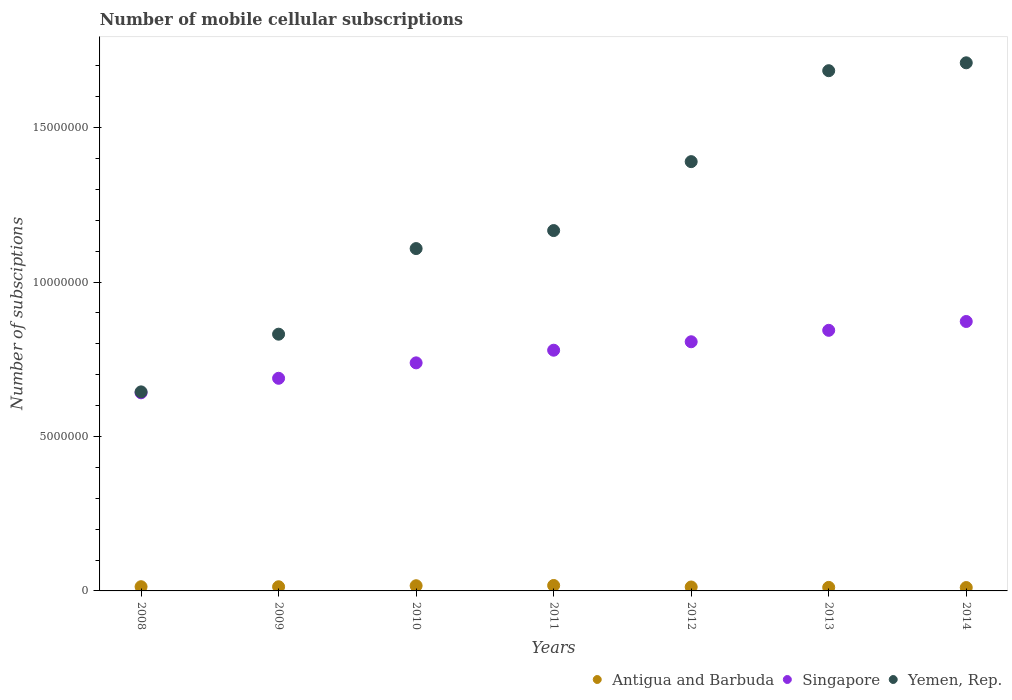How many different coloured dotlines are there?
Your answer should be compact. 3. What is the number of mobile cellular subscriptions in Antigua and Barbuda in 2012?
Offer a terse response. 1.27e+05. Across all years, what is the maximum number of mobile cellular subscriptions in Antigua and Barbuda?
Keep it short and to the point. 1.76e+05. Across all years, what is the minimum number of mobile cellular subscriptions in Yemen, Rep.?
Keep it short and to the point. 6.44e+06. In which year was the number of mobile cellular subscriptions in Antigua and Barbuda maximum?
Provide a succinct answer. 2011. What is the total number of mobile cellular subscriptions in Singapore in the graph?
Provide a short and direct response. 5.37e+07. What is the difference between the number of mobile cellular subscriptions in Singapore in 2009 and that in 2011?
Keep it short and to the point. -9.10e+05. What is the difference between the number of mobile cellular subscriptions in Singapore in 2011 and the number of mobile cellular subscriptions in Antigua and Barbuda in 2013?
Provide a succinct answer. 7.68e+06. What is the average number of mobile cellular subscriptions in Yemen, Rep. per year?
Provide a succinct answer. 1.22e+07. In the year 2008, what is the difference between the number of mobile cellular subscriptions in Singapore and number of mobile cellular subscriptions in Antigua and Barbuda?
Provide a short and direct response. 6.28e+06. In how many years, is the number of mobile cellular subscriptions in Yemen, Rep. greater than 11000000?
Offer a terse response. 5. What is the ratio of the number of mobile cellular subscriptions in Singapore in 2012 to that in 2013?
Your response must be concise. 0.96. What is the difference between the highest and the second highest number of mobile cellular subscriptions in Antigua and Barbuda?
Your answer should be compact. 8038. What is the difference between the highest and the lowest number of mobile cellular subscriptions in Antigua and Barbuda?
Provide a succinct answer. 6.69e+04. Does the number of mobile cellular subscriptions in Yemen, Rep. monotonically increase over the years?
Keep it short and to the point. Yes. Is the number of mobile cellular subscriptions in Singapore strictly greater than the number of mobile cellular subscriptions in Antigua and Barbuda over the years?
Provide a succinct answer. Yes. How many years are there in the graph?
Provide a short and direct response. 7. Does the graph contain any zero values?
Keep it short and to the point. No. Does the graph contain grids?
Give a very brief answer. No. How are the legend labels stacked?
Offer a terse response. Horizontal. What is the title of the graph?
Make the answer very short. Number of mobile cellular subscriptions. What is the label or title of the X-axis?
Provide a short and direct response. Years. What is the label or title of the Y-axis?
Your answer should be compact. Number of subsciptions. What is the Number of subsciptions of Antigua and Barbuda in 2008?
Provide a short and direct response. 1.37e+05. What is the Number of subsciptions of Singapore in 2008?
Offer a very short reply. 6.41e+06. What is the Number of subsciptions of Yemen, Rep. in 2008?
Offer a terse response. 6.44e+06. What is the Number of subsciptions in Antigua and Barbuda in 2009?
Keep it short and to the point. 1.35e+05. What is the Number of subsciptions of Singapore in 2009?
Your response must be concise. 6.88e+06. What is the Number of subsciptions in Yemen, Rep. in 2009?
Provide a short and direct response. 8.31e+06. What is the Number of subsciptions in Antigua and Barbuda in 2010?
Provide a succinct answer. 1.68e+05. What is the Number of subsciptions of Singapore in 2010?
Your answer should be compact. 7.38e+06. What is the Number of subsciptions of Yemen, Rep. in 2010?
Make the answer very short. 1.11e+07. What is the Number of subsciptions of Antigua and Barbuda in 2011?
Offer a terse response. 1.76e+05. What is the Number of subsciptions in Singapore in 2011?
Ensure brevity in your answer.  7.79e+06. What is the Number of subsciptions in Yemen, Rep. in 2011?
Provide a short and direct response. 1.17e+07. What is the Number of subsciptions in Antigua and Barbuda in 2012?
Make the answer very short. 1.27e+05. What is the Number of subsciptions in Singapore in 2012?
Make the answer very short. 8.07e+06. What is the Number of subsciptions of Yemen, Rep. in 2012?
Make the answer very short. 1.39e+07. What is the Number of subsciptions of Antigua and Barbuda in 2013?
Give a very brief answer. 1.14e+05. What is the Number of subsciptions in Singapore in 2013?
Your answer should be very brief. 8.44e+06. What is the Number of subsciptions in Yemen, Rep. in 2013?
Provide a short and direct response. 1.68e+07. What is the Number of subsciptions in Antigua and Barbuda in 2014?
Your answer should be very brief. 1.09e+05. What is the Number of subsciptions of Singapore in 2014?
Offer a very short reply. 8.72e+06. What is the Number of subsciptions of Yemen, Rep. in 2014?
Provide a succinct answer. 1.71e+07. Across all years, what is the maximum Number of subsciptions of Antigua and Barbuda?
Give a very brief answer. 1.76e+05. Across all years, what is the maximum Number of subsciptions in Singapore?
Provide a short and direct response. 8.72e+06. Across all years, what is the maximum Number of subsciptions of Yemen, Rep.?
Offer a very short reply. 1.71e+07. Across all years, what is the minimum Number of subsciptions of Antigua and Barbuda?
Provide a short and direct response. 1.09e+05. Across all years, what is the minimum Number of subsciptions in Singapore?
Provide a short and direct response. 6.41e+06. Across all years, what is the minimum Number of subsciptions in Yemen, Rep.?
Ensure brevity in your answer.  6.44e+06. What is the total Number of subsciptions in Antigua and Barbuda in the graph?
Your response must be concise. 9.66e+05. What is the total Number of subsciptions of Singapore in the graph?
Offer a very short reply. 5.37e+07. What is the total Number of subsciptions of Yemen, Rep. in the graph?
Your answer should be very brief. 8.54e+07. What is the difference between the Number of subsciptions in Antigua and Barbuda in 2008 and that in 2009?
Make the answer very short. 1667. What is the difference between the Number of subsciptions of Singapore in 2008 and that in 2009?
Offer a terse response. -4.70e+05. What is the difference between the Number of subsciptions in Yemen, Rep. in 2008 and that in 2009?
Offer a terse response. -1.87e+06. What is the difference between the Number of subsciptions in Antigua and Barbuda in 2008 and that in 2010?
Give a very brief answer. -3.14e+04. What is the difference between the Number of subsciptions of Singapore in 2008 and that in 2010?
Offer a very short reply. -9.70e+05. What is the difference between the Number of subsciptions of Yemen, Rep. in 2008 and that in 2010?
Your answer should be compact. -4.64e+06. What is the difference between the Number of subsciptions in Antigua and Barbuda in 2008 and that in 2011?
Ensure brevity in your answer.  -3.94e+04. What is the difference between the Number of subsciptions of Singapore in 2008 and that in 2011?
Ensure brevity in your answer.  -1.38e+06. What is the difference between the Number of subsciptions of Yemen, Rep. in 2008 and that in 2011?
Your answer should be compact. -5.22e+06. What is the difference between the Number of subsciptions of Antigua and Barbuda in 2008 and that in 2012?
Keep it short and to the point. 9211. What is the difference between the Number of subsciptions of Singapore in 2008 and that in 2012?
Provide a succinct answer. -1.65e+06. What is the difference between the Number of subsciptions in Yemen, Rep. in 2008 and that in 2012?
Make the answer very short. -7.46e+06. What is the difference between the Number of subsciptions in Antigua and Barbuda in 2008 and that in 2013?
Your answer should be compact. 2.22e+04. What is the difference between the Number of subsciptions in Singapore in 2008 and that in 2013?
Give a very brief answer. -2.02e+06. What is the difference between the Number of subsciptions in Yemen, Rep. in 2008 and that in 2013?
Keep it short and to the point. -1.04e+07. What is the difference between the Number of subsciptions of Antigua and Barbuda in 2008 and that in 2014?
Offer a terse response. 2.75e+04. What is the difference between the Number of subsciptions in Singapore in 2008 and that in 2014?
Provide a short and direct response. -2.31e+06. What is the difference between the Number of subsciptions of Yemen, Rep. in 2008 and that in 2014?
Provide a short and direct response. -1.07e+07. What is the difference between the Number of subsciptions in Antigua and Barbuda in 2009 and that in 2010?
Keep it short and to the point. -3.30e+04. What is the difference between the Number of subsciptions of Singapore in 2009 and that in 2010?
Offer a terse response. -5.00e+05. What is the difference between the Number of subsciptions of Yemen, Rep. in 2009 and that in 2010?
Provide a short and direct response. -2.77e+06. What is the difference between the Number of subsciptions in Antigua and Barbuda in 2009 and that in 2011?
Keep it short and to the point. -4.11e+04. What is the difference between the Number of subsciptions of Singapore in 2009 and that in 2011?
Offer a very short reply. -9.10e+05. What is the difference between the Number of subsciptions in Yemen, Rep. in 2009 and that in 2011?
Give a very brief answer. -3.36e+06. What is the difference between the Number of subsciptions in Antigua and Barbuda in 2009 and that in 2012?
Your answer should be compact. 7544. What is the difference between the Number of subsciptions of Singapore in 2009 and that in 2012?
Your answer should be compact. -1.18e+06. What is the difference between the Number of subsciptions of Yemen, Rep. in 2009 and that in 2012?
Ensure brevity in your answer.  -5.59e+06. What is the difference between the Number of subsciptions of Antigua and Barbuda in 2009 and that in 2013?
Your answer should be compact. 2.06e+04. What is the difference between the Number of subsciptions in Singapore in 2009 and that in 2013?
Provide a succinct answer. -1.55e+06. What is the difference between the Number of subsciptions in Yemen, Rep. in 2009 and that in 2013?
Make the answer very short. -8.53e+06. What is the difference between the Number of subsciptions in Antigua and Barbuda in 2009 and that in 2014?
Ensure brevity in your answer.  2.58e+04. What is the difference between the Number of subsciptions in Singapore in 2009 and that in 2014?
Give a very brief answer. -1.84e+06. What is the difference between the Number of subsciptions in Yemen, Rep. in 2009 and that in 2014?
Provide a succinct answer. -8.79e+06. What is the difference between the Number of subsciptions in Antigua and Barbuda in 2010 and that in 2011?
Offer a very short reply. -8038. What is the difference between the Number of subsciptions of Singapore in 2010 and that in 2011?
Your answer should be very brief. -4.10e+05. What is the difference between the Number of subsciptions of Yemen, Rep. in 2010 and that in 2011?
Your response must be concise. -5.83e+05. What is the difference between the Number of subsciptions of Antigua and Barbuda in 2010 and that in 2012?
Offer a very short reply. 4.06e+04. What is the difference between the Number of subsciptions of Singapore in 2010 and that in 2012?
Your response must be concise. -6.83e+05. What is the difference between the Number of subsciptions in Yemen, Rep. in 2010 and that in 2012?
Your answer should be compact. -2.82e+06. What is the difference between the Number of subsciptions of Antigua and Barbuda in 2010 and that in 2013?
Ensure brevity in your answer.  5.36e+04. What is the difference between the Number of subsciptions of Singapore in 2010 and that in 2013?
Offer a very short reply. -1.05e+06. What is the difference between the Number of subsciptions in Yemen, Rep. in 2010 and that in 2013?
Your response must be concise. -5.76e+06. What is the difference between the Number of subsciptions of Antigua and Barbuda in 2010 and that in 2014?
Offer a terse response. 5.89e+04. What is the difference between the Number of subsciptions in Singapore in 2010 and that in 2014?
Provide a short and direct response. -1.34e+06. What is the difference between the Number of subsciptions of Yemen, Rep. in 2010 and that in 2014?
Your response must be concise. -6.02e+06. What is the difference between the Number of subsciptions of Antigua and Barbuda in 2011 and that in 2012?
Provide a short and direct response. 4.86e+04. What is the difference between the Number of subsciptions of Singapore in 2011 and that in 2012?
Provide a succinct answer. -2.73e+05. What is the difference between the Number of subsciptions of Yemen, Rep. in 2011 and that in 2012?
Offer a terse response. -2.23e+06. What is the difference between the Number of subsciptions in Antigua and Barbuda in 2011 and that in 2013?
Provide a succinct answer. 6.16e+04. What is the difference between the Number of subsciptions of Singapore in 2011 and that in 2013?
Keep it short and to the point. -6.44e+05. What is the difference between the Number of subsciptions in Yemen, Rep. in 2011 and that in 2013?
Ensure brevity in your answer.  -5.18e+06. What is the difference between the Number of subsciptions in Antigua and Barbuda in 2011 and that in 2014?
Offer a very short reply. 6.69e+04. What is the difference between the Number of subsciptions of Singapore in 2011 and that in 2014?
Offer a terse response. -9.30e+05. What is the difference between the Number of subsciptions of Yemen, Rep. in 2011 and that in 2014?
Provide a short and direct response. -5.43e+06. What is the difference between the Number of subsciptions of Antigua and Barbuda in 2012 and that in 2013?
Offer a very short reply. 1.30e+04. What is the difference between the Number of subsciptions of Singapore in 2012 and that in 2013?
Offer a very short reply. -3.70e+05. What is the difference between the Number of subsciptions in Yemen, Rep. in 2012 and that in 2013?
Your answer should be very brief. -2.94e+06. What is the difference between the Number of subsciptions in Antigua and Barbuda in 2012 and that in 2014?
Offer a very short reply. 1.83e+04. What is the difference between the Number of subsciptions in Singapore in 2012 and that in 2014?
Provide a short and direct response. -6.57e+05. What is the difference between the Number of subsciptions of Yemen, Rep. in 2012 and that in 2014?
Keep it short and to the point. -3.20e+06. What is the difference between the Number of subsciptions of Antigua and Barbuda in 2013 and that in 2014?
Your answer should be compact. 5258. What is the difference between the Number of subsciptions in Singapore in 2013 and that in 2014?
Offer a terse response. -2.86e+05. What is the difference between the Number of subsciptions of Yemen, Rep. in 2013 and that in 2014?
Your response must be concise. -2.55e+05. What is the difference between the Number of subsciptions of Antigua and Barbuda in 2008 and the Number of subsciptions of Singapore in 2009?
Provide a short and direct response. -6.75e+06. What is the difference between the Number of subsciptions of Antigua and Barbuda in 2008 and the Number of subsciptions of Yemen, Rep. in 2009?
Give a very brief answer. -8.18e+06. What is the difference between the Number of subsciptions in Singapore in 2008 and the Number of subsciptions in Yemen, Rep. in 2009?
Your response must be concise. -1.90e+06. What is the difference between the Number of subsciptions in Antigua and Barbuda in 2008 and the Number of subsciptions in Singapore in 2010?
Provide a short and direct response. -7.25e+06. What is the difference between the Number of subsciptions in Antigua and Barbuda in 2008 and the Number of subsciptions in Yemen, Rep. in 2010?
Provide a short and direct response. -1.09e+07. What is the difference between the Number of subsciptions of Singapore in 2008 and the Number of subsciptions of Yemen, Rep. in 2010?
Your answer should be very brief. -4.67e+06. What is the difference between the Number of subsciptions of Antigua and Barbuda in 2008 and the Number of subsciptions of Singapore in 2011?
Your answer should be very brief. -7.66e+06. What is the difference between the Number of subsciptions of Antigua and Barbuda in 2008 and the Number of subsciptions of Yemen, Rep. in 2011?
Give a very brief answer. -1.15e+07. What is the difference between the Number of subsciptions in Singapore in 2008 and the Number of subsciptions in Yemen, Rep. in 2011?
Provide a short and direct response. -5.25e+06. What is the difference between the Number of subsciptions of Antigua and Barbuda in 2008 and the Number of subsciptions of Singapore in 2012?
Ensure brevity in your answer.  -7.93e+06. What is the difference between the Number of subsciptions of Antigua and Barbuda in 2008 and the Number of subsciptions of Yemen, Rep. in 2012?
Make the answer very short. -1.38e+07. What is the difference between the Number of subsciptions of Singapore in 2008 and the Number of subsciptions of Yemen, Rep. in 2012?
Your answer should be very brief. -7.49e+06. What is the difference between the Number of subsciptions in Antigua and Barbuda in 2008 and the Number of subsciptions in Singapore in 2013?
Offer a terse response. -8.30e+06. What is the difference between the Number of subsciptions of Antigua and Barbuda in 2008 and the Number of subsciptions of Yemen, Rep. in 2013?
Your response must be concise. -1.67e+07. What is the difference between the Number of subsciptions of Singapore in 2008 and the Number of subsciptions of Yemen, Rep. in 2013?
Offer a very short reply. -1.04e+07. What is the difference between the Number of subsciptions in Antigua and Barbuda in 2008 and the Number of subsciptions in Singapore in 2014?
Provide a succinct answer. -8.59e+06. What is the difference between the Number of subsciptions in Antigua and Barbuda in 2008 and the Number of subsciptions in Yemen, Rep. in 2014?
Offer a terse response. -1.70e+07. What is the difference between the Number of subsciptions of Singapore in 2008 and the Number of subsciptions of Yemen, Rep. in 2014?
Offer a terse response. -1.07e+07. What is the difference between the Number of subsciptions of Antigua and Barbuda in 2009 and the Number of subsciptions of Singapore in 2010?
Make the answer very short. -7.25e+06. What is the difference between the Number of subsciptions in Antigua and Barbuda in 2009 and the Number of subsciptions in Yemen, Rep. in 2010?
Offer a terse response. -1.10e+07. What is the difference between the Number of subsciptions of Singapore in 2009 and the Number of subsciptions of Yemen, Rep. in 2010?
Your answer should be compact. -4.20e+06. What is the difference between the Number of subsciptions in Antigua and Barbuda in 2009 and the Number of subsciptions in Singapore in 2011?
Ensure brevity in your answer.  -7.66e+06. What is the difference between the Number of subsciptions of Antigua and Barbuda in 2009 and the Number of subsciptions of Yemen, Rep. in 2011?
Make the answer very short. -1.15e+07. What is the difference between the Number of subsciptions of Singapore in 2009 and the Number of subsciptions of Yemen, Rep. in 2011?
Ensure brevity in your answer.  -4.78e+06. What is the difference between the Number of subsciptions of Antigua and Barbuda in 2009 and the Number of subsciptions of Singapore in 2012?
Provide a succinct answer. -7.93e+06. What is the difference between the Number of subsciptions of Antigua and Barbuda in 2009 and the Number of subsciptions of Yemen, Rep. in 2012?
Your answer should be very brief. -1.38e+07. What is the difference between the Number of subsciptions in Singapore in 2009 and the Number of subsciptions in Yemen, Rep. in 2012?
Make the answer very short. -7.02e+06. What is the difference between the Number of subsciptions in Antigua and Barbuda in 2009 and the Number of subsciptions in Singapore in 2013?
Your answer should be compact. -8.30e+06. What is the difference between the Number of subsciptions of Antigua and Barbuda in 2009 and the Number of subsciptions of Yemen, Rep. in 2013?
Offer a terse response. -1.67e+07. What is the difference between the Number of subsciptions in Singapore in 2009 and the Number of subsciptions in Yemen, Rep. in 2013?
Make the answer very short. -9.96e+06. What is the difference between the Number of subsciptions of Antigua and Barbuda in 2009 and the Number of subsciptions of Singapore in 2014?
Keep it short and to the point. -8.59e+06. What is the difference between the Number of subsciptions of Antigua and Barbuda in 2009 and the Number of subsciptions of Yemen, Rep. in 2014?
Your answer should be very brief. -1.70e+07. What is the difference between the Number of subsciptions of Singapore in 2009 and the Number of subsciptions of Yemen, Rep. in 2014?
Give a very brief answer. -1.02e+07. What is the difference between the Number of subsciptions in Antigua and Barbuda in 2010 and the Number of subsciptions in Singapore in 2011?
Your answer should be compact. -7.63e+06. What is the difference between the Number of subsciptions of Antigua and Barbuda in 2010 and the Number of subsciptions of Yemen, Rep. in 2011?
Provide a succinct answer. -1.15e+07. What is the difference between the Number of subsciptions in Singapore in 2010 and the Number of subsciptions in Yemen, Rep. in 2011?
Provide a short and direct response. -4.28e+06. What is the difference between the Number of subsciptions of Antigua and Barbuda in 2010 and the Number of subsciptions of Singapore in 2012?
Your answer should be very brief. -7.90e+06. What is the difference between the Number of subsciptions in Antigua and Barbuda in 2010 and the Number of subsciptions in Yemen, Rep. in 2012?
Provide a short and direct response. -1.37e+07. What is the difference between the Number of subsciptions of Singapore in 2010 and the Number of subsciptions of Yemen, Rep. in 2012?
Provide a short and direct response. -6.52e+06. What is the difference between the Number of subsciptions of Antigua and Barbuda in 2010 and the Number of subsciptions of Singapore in 2013?
Provide a short and direct response. -8.27e+06. What is the difference between the Number of subsciptions in Antigua and Barbuda in 2010 and the Number of subsciptions in Yemen, Rep. in 2013?
Make the answer very short. -1.67e+07. What is the difference between the Number of subsciptions in Singapore in 2010 and the Number of subsciptions in Yemen, Rep. in 2013?
Provide a succinct answer. -9.46e+06. What is the difference between the Number of subsciptions in Antigua and Barbuda in 2010 and the Number of subsciptions in Singapore in 2014?
Your answer should be very brief. -8.56e+06. What is the difference between the Number of subsciptions in Antigua and Barbuda in 2010 and the Number of subsciptions in Yemen, Rep. in 2014?
Provide a succinct answer. -1.69e+07. What is the difference between the Number of subsciptions in Singapore in 2010 and the Number of subsciptions in Yemen, Rep. in 2014?
Provide a short and direct response. -9.72e+06. What is the difference between the Number of subsciptions of Antigua and Barbuda in 2011 and the Number of subsciptions of Singapore in 2012?
Provide a succinct answer. -7.89e+06. What is the difference between the Number of subsciptions in Antigua and Barbuda in 2011 and the Number of subsciptions in Yemen, Rep. in 2012?
Provide a short and direct response. -1.37e+07. What is the difference between the Number of subsciptions of Singapore in 2011 and the Number of subsciptions of Yemen, Rep. in 2012?
Your answer should be very brief. -6.11e+06. What is the difference between the Number of subsciptions in Antigua and Barbuda in 2011 and the Number of subsciptions in Singapore in 2013?
Your answer should be very brief. -8.26e+06. What is the difference between the Number of subsciptions in Antigua and Barbuda in 2011 and the Number of subsciptions in Yemen, Rep. in 2013?
Provide a short and direct response. -1.67e+07. What is the difference between the Number of subsciptions of Singapore in 2011 and the Number of subsciptions of Yemen, Rep. in 2013?
Make the answer very short. -9.05e+06. What is the difference between the Number of subsciptions of Antigua and Barbuda in 2011 and the Number of subsciptions of Singapore in 2014?
Provide a short and direct response. -8.55e+06. What is the difference between the Number of subsciptions of Antigua and Barbuda in 2011 and the Number of subsciptions of Yemen, Rep. in 2014?
Provide a succinct answer. -1.69e+07. What is the difference between the Number of subsciptions in Singapore in 2011 and the Number of subsciptions in Yemen, Rep. in 2014?
Offer a terse response. -9.31e+06. What is the difference between the Number of subsciptions in Antigua and Barbuda in 2012 and the Number of subsciptions in Singapore in 2013?
Offer a terse response. -8.31e+06. What is the difference between the Number of subsciptions in Antigua and Barbuda in 2012 and the Number of subsciptions in Yemen, Rep. in 2013?
Offer a very short reply. -1.67e+07. What is the difference between the Number of subsciptions of Singapore in 2012 and the Number of subsciptions of Yemen, Rep. in 2013?
Provide a short and direct response. -8.78e+06. What is the difference between the Number of subsciptions of Antigua and Barbuda in 2012 and the Number of subsciptions of Singapore in 2014?
Give a very brief answer. -8.60e+06. What is the difference between the Number of subsciptions in Antigua and Barbuda in 2012 and the Number of subsciptions in Yemen, Rep. in 2014?
Keep it short and to the point. -1.70e+07. What is the difference between the Number of subsciptions of Singapore in 2012 and the Number of subsciptions of Yemen, Rep. in 2014?
Provide a short and direct response. -9.03e+06. What is the difference between the Number of subsciptions in Antigua and Barbuda in 2013 and the Number of subsciptions in Singapore in 2014?
Make the answer very short. -8.61e+06. What is the difference between the Number of subsciptions in Antigua and Barbuda in 2013 and the Number of subsciptions in Yemen, Rep. in 2014?
Provide a short and direct response. -1.70e+07. What is the difference between the Number of subsciptions of Singapore in 2013 and the Number of subsciptions of Yemen, Rep. in 2014?
Offer a terse response. -8.66e+06. What is the average Number of subsciptions in Antigua and Barbuda per year?
Provide a succinct answer. 1.38e+05. What is the average Number of subsciptions in Singapore per year?
Provide a short and direct response. 7.67e+06. What is the average Number of subsciptions in Yemen, Rep. per year?
Your answer should be compact. 1.22e+07. In the year 2008, what is the difference between the Number of subsciptions of Antigua and Barbuda and Number of subsciptions of Singapore?
Keep it short and to the point. -6.28e+06. In the year 2008, what is the difference between the Number of subsciptions in Antigua and Barbuda and Number of subsciptions in Yemen, Rep.?
Offer a very short reply. -6.31e+06. In the year 2008, what is the difference between the Number of subsciptions in Singapore and Number of subsciptions in Yemen, Rep.?
Provide a short and direct response. -3.02e+04. In the year 2009, what is the difference between the Number of subsciptions of Antigua and Barbuda and Number of subsciptions of Singapore?
Ensure brevity in your answer.  -6.75e+06. In the year 2009, what is the difference between the Number of subsciptions in Antigua and Barbuda and Number of subsciptions in Yemen, Rep.?
Make the answer very short. -8.18e+06. In the year 2009, what is the difference between the Number of subsciptions in Singapore and Number of subsciptions in Yemen, Rep.?
Give a very brief answer. -1.43e+06. In the year 2010, what is the difference between the Number of subsciptions of Antigua and Barbuda and Number of subsciptions of Singapore?
Your response must be concise. -7.22e+06. In the year 2010, what is the difference between the Number of subsciptions of Antigua and Barbuda and Number of subsciptions of Yemen, Rep.?
Offer a terse response. -1.09e+07. In the year 2010, what is the difference between the Number of subsciptions of Singapore and Number of subsciptions of Yemen, Rep.?
Provide a short and direct response. -3.70e+06. In the year 2011, what is the difference between the Number of subsciptions of Antigua and Barbuda and Number of subsciptions of Singapore?
Make the answer very short. -7.62e+06. In the year 2011, what is the difference between the Number of subsciptions in Antigua and Barbuda and Number of subsciptions in Yemen, Rep.?
Offer a terse response. -1.15e+07. In the year 2011, what is the difference between the Number of subsciptions of Singapore and Number of subsciptions of Yemen, Rep.?
Make the answer very short. -3.87e+06. In the year 2012, what is the difference between the Number of subsciptions of Antigua and Barbuda and Number of subsciptions of Singapore?
Ensure brevity in your answer.  -7.94e+06. In the year 2012, what is the difference between the Number of subsciptions in Antigua and Barbuda and Number of subsciptions in Yemen, Rep.?
Offer a terse response. -1.38e+07. In the year 2012, what is the difference between the Number of subsciptions in Singapore and Number of subsciptions in Yemen, Rep.?
Your answer should be very brief. -5.83e+06. In the year 2013, what is the difference between the Number of subsciptions of Antigua and Barbuda and Number of subsciptions of Singapore?
Give a very brief answer. -8.32e+06. In the year 2013, what is the difference between the Number of subsciptions of Antigua and Barbuda and Number of subsciptions of Yemen, Rep.?
Provide a succinct answer. -1.67e+07. In the year 2013, what is the difference between the Number of subsciptions of Singapore and Number of subsciptions of Yemen, Rep.?
Offer a very short reply. -8.41e+06. In the year 2014, what is the difference between the Number of subsciptions in Antigua and Barbuda and Number of subsciptions in Singapore?
Make the answer very short. -8.62e+06. In the year 2014, what is the difference between the Number of subsciptions of Antigua and Barbuda and Number of subsciptions of Yemen, Rep.?
Your response must be concise. -1.70e+07. In the year 2014, what is the difference between the Number of subsciptions in Singapore and Number of subsciptions in Yemen, Rep.?
Your answer should be very brief. -8.38e+06. What is the ratio of the Number of subsciptions of Antigua and Barbuda in 2008 to that in 2009?
Make the answer very short. 1.01. What is the ratio of the Number of subsciptions in Singapore in 2008 to that in 2009?
Ensure brevity in your answer.  0.93. What is the ratio of the Number of subsciptions in Yemen, Rep. in 2008 to that in 2009?
Make the answer very short. 0.78. What is the ratio of the Number of subsciptions in Antigua and Barbuda in 2008 to that in 2010?
Offer a very short reply. 0.81. What is the ratio of the Number of subsciptions in Singapore in 2008 to that in 2010?
Provide a short and direct response. 0.87. What is the ratio of the Number of subsciptions of Yemen, Rep. in 2008 to that in 2010?
Your response must be concise. 0.58. What is the ratio of the Number of subsciptions of Antigua and Barbuda in 2008 to that in 2011?
Offer a very short reply. 0.78. What is the ratio of the Number of subsciptions of Singapore in 2008 to that in 2011?
Your answer should be very brief. 0.82. What is the ratio of the Number of subsciptions in Yemen, Rep. in 2008 to that in 2011?
Provide a succinct answer. 0.55. What is the ratio of the Number of subsciptions of Antigua and Barbuda in 2008 to that in 2012?
Offer a very short reply. 1.07. What is the ratio of the Number of subsciptions of Singapore in 2008 to that in 2012?
Provide a succinct answer. 0.8. What is the ratio of the Number of subsciptions in Yemen, Rep. in 2008 to that in 2012?
Your answer should be very brief. 0.46. What is the ratio of the Number of subsciptions of Antigua and Barbuda in 2008 to that in 2013?
Keep it short and to the point. 1.19. What is the ratio of the Number of subsciptions of Singapore in 2008 to that in 2013?
Ensure brevity in your answer.  0.76. What is the ratio of the Number of subsciptions of Yemen, Rep. in 2008 to that in 2013?
Provide a succinct answer. 0.38. What is the ratio of the Number of subsciptions in Antigua and Barbuda in 2008 to that in 2014?
Give a very brief answer. 1.25. What is the ratio of the Number of subsciptions of Singapore in 2008 to that in 2014?
Ensure brevity in your answer.  0.74. What is the ratio of the Number of subsciptions of Yemen, Rep. in 2008 to that in 2014?
Make the answer very short. 0.38. What is the ratio of the Number of subsciptions in Antigua and Barbuda in 2009 to that in 2010?
Offer a very short reply. 0.8. What is the ratio of the Number of subsciptions in Singapore in 2009 to that in 2010?
Provide a succinct answer. 0.93. What is the ratio of the Number of subsciptions in Yemen, Rep. in 2009 to that in 2010?
Offer a terse response. 0.75. What is the ratio of the Number of subsciptions of Antigua and Barbuda in 2009 to that in 2011?
Provide a short and direct response. 0.77. What is the ratio of the Number of subsciptions of Singapore in 2009 to that in 2011?
Ensure brevity in your answer.  0.88. What is the ratio of the Number of subsciptions in Yemen, Rep. in 2009 to that in 2011?
Give a very brief answer. 0.71. What is the ratio of the Number of subsciptions in Antigua and Barbuda in 2009 to that in 2012?
Provide a succinct answer. 1.06. What is the ratio of the Number of subsciptions in Singapore in 2009 to that in 2012?
Provide a short and direct response. 0.85. What is the ratio of the Number of subsciptions of Yemen, Rep. in 2009 to that in 2012?
Give a very brief answer. 0.6. What is the ratio of the Number of subsciptions in Antigua and Barbuda in 2009 to that in 2013?
Give a very brief answer. 1.18. What is the ratio of the Number of subsciptions in Singapore in 2009 to that in 2013?
Offer a very short reply. 0.82. What is the ratio of the Number of subsciptions of Yemen, Rep. in 2009 to that in 2013?
Your response must be concise. 0.49. What is the ratio of the Number of subsciptions of Antigua and Barbuda in 2009 to that in 2014?
Provide a succinct answer. 1.24. What is the ratio of the Number of subsciptions in Singapore in 2009 to that in 2014?
Your answer should be very brief. 0.79. What is the ratio of the Number of subsciptions in Yemen, Rep. in 2009 to that in 2014?
Offer a terse response. 0.49. What is the ratio of the Number of subsciptions of Antigua and Barbuda in 2010 to that in 2011?
Ensure brevity in your answer.  0.95. What is the ratio of the Number of subsciptions of Singapore in 2010 to that in 2011?
Offer a terse response. 0.95. What is the ratio of the Number of subsciptions in Yemen, Rep. in 2010 to that in 2011?
Keep it short and to the point. 0.95. What is the ratio of the Number of subsciptions in Antigua and Barbuda in 2010 to that in 2012?
Give a very brief answer. 1.32. What is the ratio of the Number of subsciptions in Singapore in 2010 to that in 2012?
Your response must be concise. 0.92. What is the ratio of the Number of subsciptions in Yemen, Rep. in 2010 to that in 2012?
Provide a succinct answer. 0.8. What is the ratio of the Number of subsciptions in Antigua and Barbuda in 2010 to that in 2013?
Offer a very short reply. 1.47. What is the ratio of the Number of subsciptions of Singapore in 2010 to that in 2013?
Your answer should be very brief. 0.88. What is the ratio of the Number of subsciptions in Yemen, Rep. in 2010 to that in 2013?
Your answer should be compact. 0.66. What is the ratio of the Number of subsciptions in Antigua and Barbuda in 2010 to that in 2014?
Give a very brief answer. 1.54. What is the ratio of the Number of subsciptions of Singapore in 2010 to that in 2014?
Your response must be concise. 0.85. What is the ratio of the Number of subsciptions in Yemen, Rep. in 2010 to that in 2014?
Your response must be concise. 0.65. What is the ratio of the Number of subsciptions in Antigua and Barbuda in 2011 to that in 2012?
Make the answer very short. 1.38. What is the ratio of the Number of subsciptions in Singapore in 2011 to that in 2012?
Ensure brevity in your answer.  0.97. What is the ratio of the Number of subsciptions in Yemen, Rep. in 2011 to that in 2012?
Keep it short and to the point. 0.84. What is the ratio of the Number of subsciptions in Antigua and Barbuda in 2011 to that in 2013?
Ensure brevity in your answer.  1.54. What is the ratio of the Number of subsciptions of Singapore in 2011 to that in 2013?
Your response must be concise. 0.92. What is the ratio of the Number of subsciptions in Yemen, Rep. in 2011 to that in 2013?
Your answer should be very brief. 0.69. What is the ratio of the Number of subsciptions of Antigua and Barbuda in 2011 to that in 2014?
Give a very brief answer. 1.61. What is the ratio of the Number of subsciptions of Singapore in 2011 to that in 2014?
Offer a terse response. 0.89. What is the ratio of the Number of subsciptions in Yemen, Rep. in 2011 to that in 2014?
Give a very brief answer. 0.68. What is the ratio of the Number of subsciptions of Antigua and Barbuda in 2012 to that in 2013?
Make the answer very short. 1.11. What is the ratio of the Number of subsciptions of Singapore in 2012 to that in 2013?
Your response must be concise. 0.96. What is the ratio of the Number of subsciptions in Yemen, Rep. in 2012 to that in 2013?
Your response must be concise. 0.83. What is the ratio of the Number of subsciptions of Antigua and Barbuda in 2012 to that in 2014?
Your response must be concise. 1.17. What is the ratio of the Number of subsciptions of Singapore in 2012 to that in 2014?
Ensure brevity in your answer.  0.92. What is the ratio of the Number of subsciptions in Yemen, Rep. in 2012 to that in 2014?
Your response must be concise. 0.81. What is the ratio of the Number of subsciptions of Antigua and Barbuda in 2013 to that in 2014?
Give a very brief answer. 1.05. What is the ratio of the Number of subsciptions of Singapore in 2013 to that in 2014?
Make the answer very short. 0.97. What is the ratio of the Number of subsciptions of Yemen, Rep. in 2013 to that in 2014?
Keep it short and to the point. 0.99. What is the difference between the highest and the second highest Number of subsciptions in Antigua and Barbuda?
Provide a succinct answer. 8038. What is the difference between the highest and the second highest Number of subsciptions of Singapore?
Give a very brief answer. 2.86e+05. What is the difference between the highest and the second highest Number of subsciptions in Yemen, Rep.?
Provide a succinct answer. 2.55e+05. What is the difference between the highest and the lowest Number of subsciptions of Antigua and Barbuda?
Offer a very short reply. 6.69e+04. What is the difference between the highest and the lowest Number of subsciptions in Singapore?
Keep it short and to the point. 2.31e+06. What is the difference between the highest and the lowest Number of subsciptions in Yemen, Rep.?
Make the answer very short. 1.07e+07. 